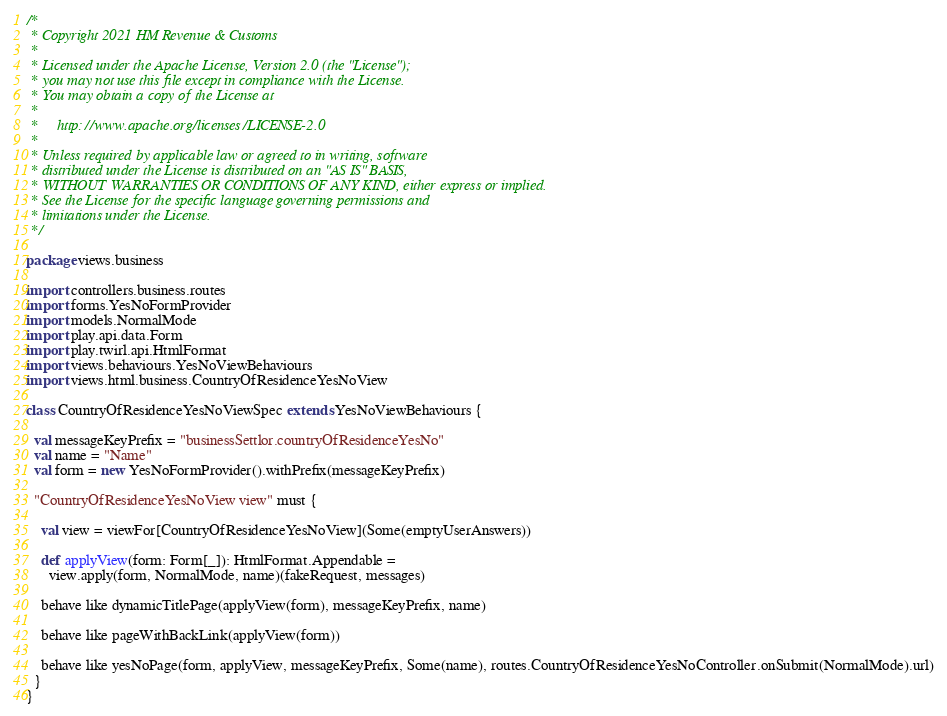<code> <loc_0><loc_0><loc_500><loc_500><_Scala_>/*
 * Copyright 2021 HM Revenue & Customs
 *
 * Licensed under the Apache License, Version 2.0 (the "License");
 * you may not use this file except in compliance with the License.
 * You may obtain a copy of the License at
 *
 *     http://www.apache.org/licenses/LICENSE-2.0
 *
 * Unless required by applicable law or agreed to in writing, software
 * distributed under the License is distributed on an "AS IS" BASIS,
 * WITHOUT WARRANTIES OR CONDITIONS OF ANY KIND, either express or implied.
 * See the License for the specific language governing permissions and
 * limitations under the License.
 */

package views.business

import controllers.business.routes
import forms.YesNoFormProvider
import models.NormalMode
import play.api.data.Form
import play.twirl.api.HtmlFormat
import views.behaviours.YesNoViewBehaviours
import views.html.business.CountryOfResidenceYesNoView

class CountryOfResidenceYesNoViewSpec extends YesNoViewBehaviours {

  val messageKeyPrefix = "businessSettlor.countryOfResidenceYesNo"
  val name = "Name"
  val form = new YesNoFormProvider().withPrefix(messageKeyPrefix)

  "CountryOfResidenceYesNoView view" must {

    val view = viewFor[CountryOfResidenceYesNoView](Some(emptyUserAnswers))

    def applyView(form: Form[_]): HtmlFormat.Appendable =
      view.apply(form, NormalMode, name)(fakeRequest, messages)

    behave like dynamicTitlePage(applyView(form), messageKeyPrefix, name)

    behave like pageWithBackLink(applyView(form))

    behave like yesNoPage(form, applyView, messageKeyPrefix, Some(name), routes.CountryOfResidenceYesNoController.onSubmit(NormalMode).url)
  }
}
</code> 